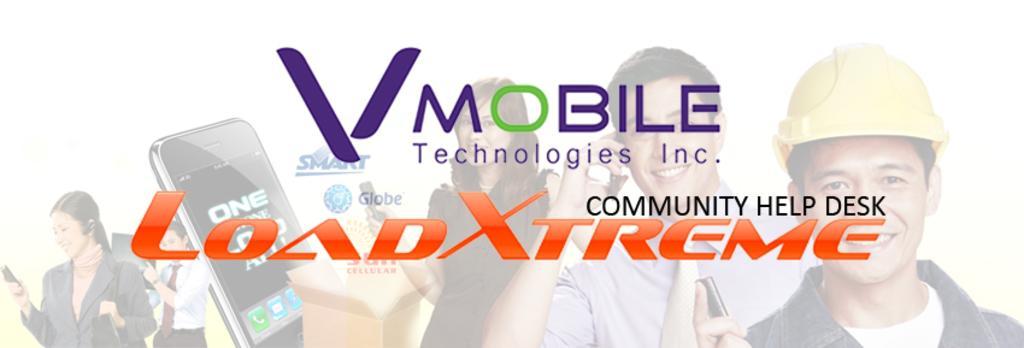Describe this image in one or two sentences. In this image there are some text written and there are persons smiling and there are objects which are black and brown in colour. 